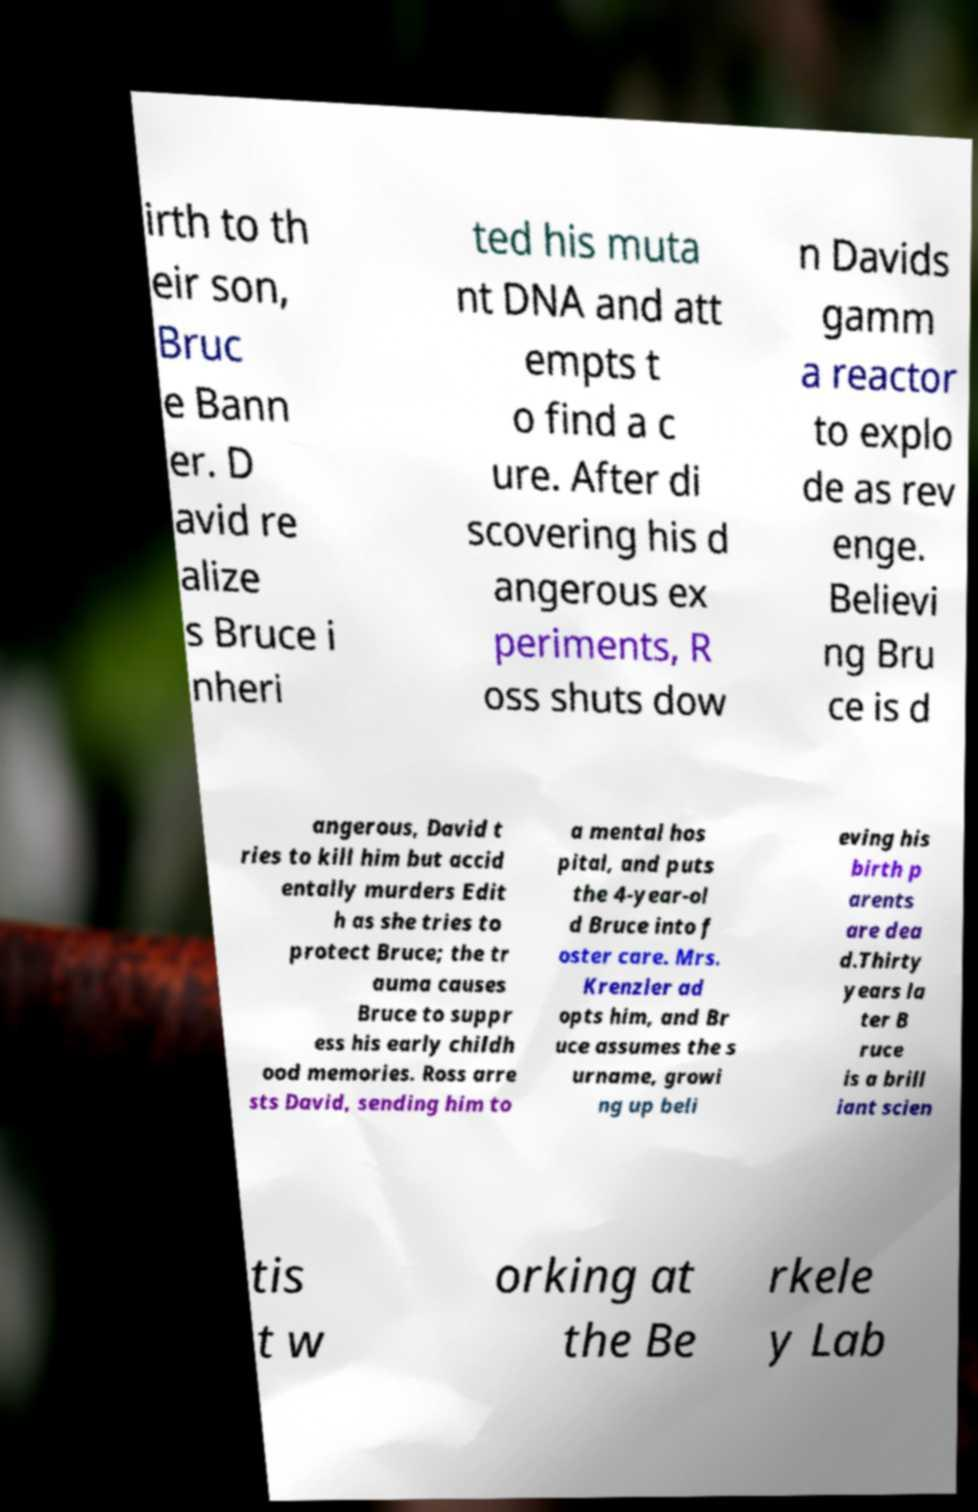Could you extract and type out the text from this image? irth to th eir son, Bruc e Bann er. D avid re alize s Bruce i nheri ted his muta nt DNA and att empts t o find a c ure. After di scovering his d angerous ex periments, R oss shuts dow n Davids gamm a reactor to explo de as rev enge. Believi ng Bru ce is d angerous, David t ries to kill him but accid entally murders Edit h as she tries to protect Bruce; the tr auma causes Bruce to suppr ess his early childh ood memories. Ross arre sts David, sending him to a mental hos pital, and puts the 4-year-ol d Bruce into f oster care. Mrs. Krenzler ad opts him, and Br uce assumes the s urname, growi ng up beli eving his birth p arents are dea d.Thirty years la ter B ruce is a brill iant scien tis t w orking at the Be rkele y Lab 